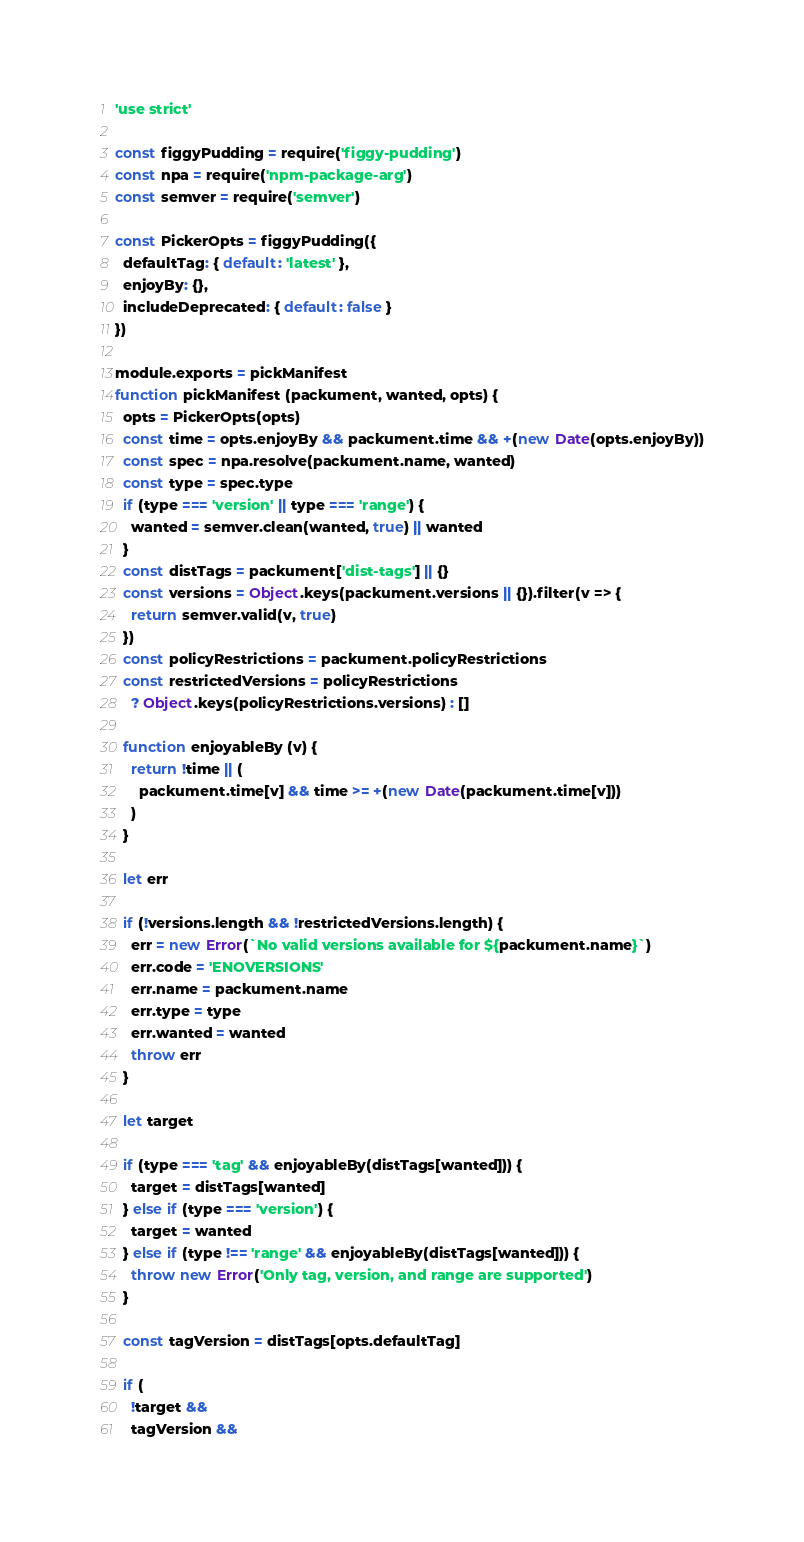<code> <loc_0><loc_0><loc_500><loc_500><_JavaScript_>'use strict'

const figgyPudding = require('figgy-pudding')
const npa = require('npm-package-arg')
const semver = require('semver')

const PickerOpts = figgyPudding({
  defaultTag: { default: 'latest' },
  enjoyBy: {},
  includeDeprecated: { default: false }
})

module.exports = pickManifest
function pickManifest (packument, wanted, opts) {
  opts = PickerOpts(opts)
  const time = opts.enjoyBy && packument.time && +(new Date(opts.enjoyBy))
  const spec = npa.resolve(packument.name, wanted)
  const type = spec.type
  if (type === 'version' || type === 'range') {
    wanted = semver.clean(wanted, true) || wanted
  }
  const distTags = packument['dist-tags'] || {}
  const versions = Object.keys(packument.versions || {}).filter(v => {
    return semver.valid(v, true)
  })
  const policyRestrictions = packument.policyRestrictions
  const restrictedVersions = policyRestrictions
    ? Object.keys(policyRestrictions.versions) : []

  function enjoyableBy (v) {
    return !time || (
      packument.time[v] && time >= +(new Date(packument.time[v]))
    )
  }

  let err

  if (!versions.length && !restrictedVersions.length) {
    err = new Error(`No valid versions available for ${packument.name}`)
    err.code = 'ENOVERSIONS'
    err.name = packument.name
    err.type = type
    err.wanted = wanted
    throw err
  }

  let target

  if (type === 'tag' && enjoyableBy(distTags[wanted])) {
    target = distTags[wanted]
  } else if (type === 'version') {
    target = wanted
  } else if (type !== 'range' && enjoyableBy(distTags[wanted])) {
    throw new Error('Only tag, version, and range are supported')
  }

  const tagVersion = distTags[opts.defaultTag]

  if (
    !target &&
    tagVersion &&</code> 